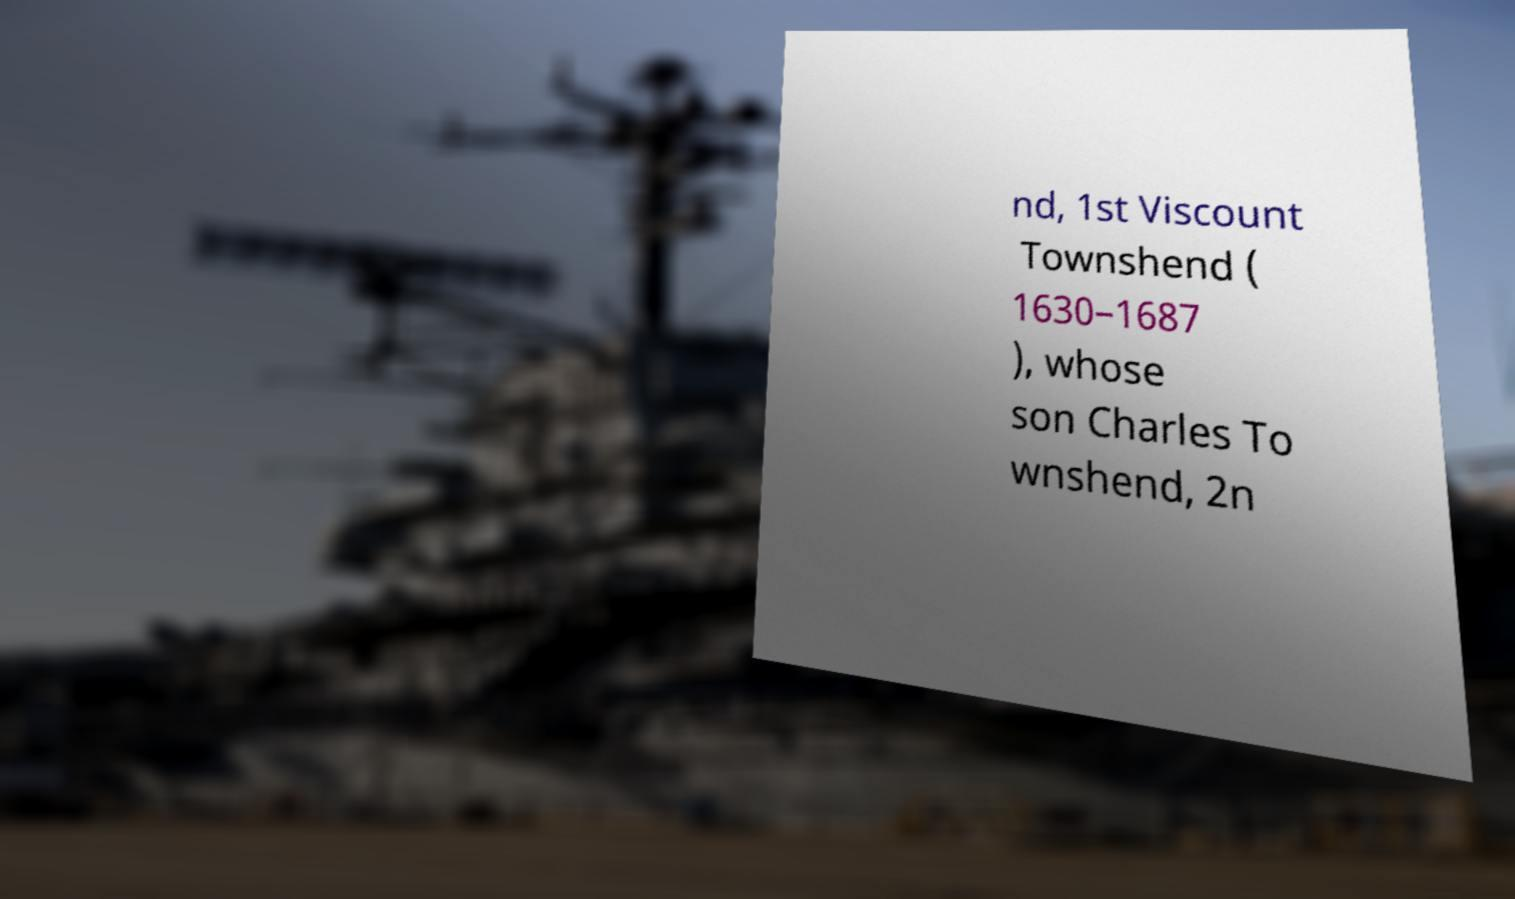Could you assist in decoding the text presented in this image and type it out clearly? nd, 1st Viscount Townshend ( 1630–1687 ), whose son Charles To wnshend, 2n 